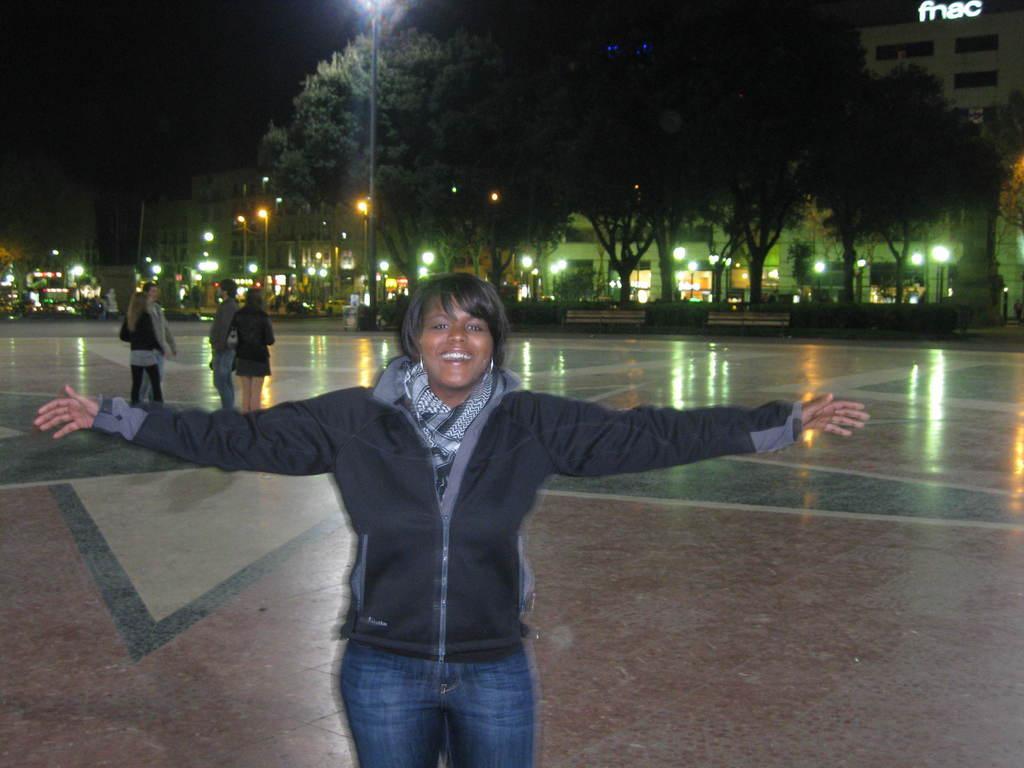Can you describe this image briefly? In this picture I can see there is a woman standing she is wearing a black coat and in the backdrop there are few people standing and there are poles, lights, trees, buildings. 